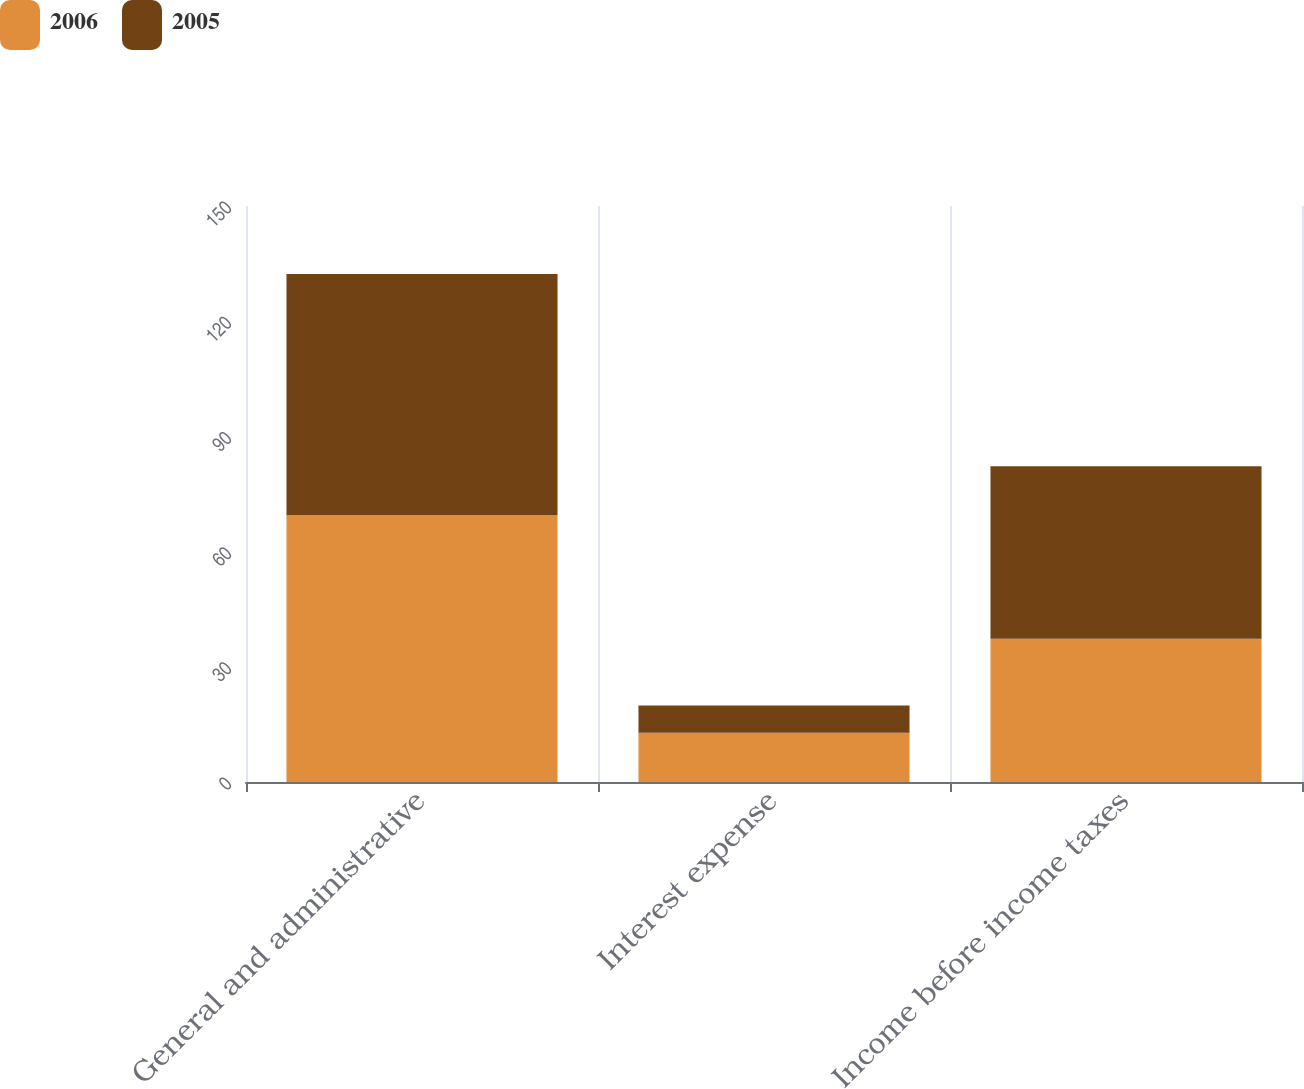Convert chart. <chart><loc_0><loc_0><loc_500><loc_500><stacked_bar_chart><ecel><fcel>General and administrative<fcel>Interest expense<fcel>Income before income taxes<nl><fcel>2006<fcel>69.5<fcel>12.8<fcel>37.3<nl><fcel>2005<fcel>62.8<fcel>7.1<fcel>44.9<nl></chart> 